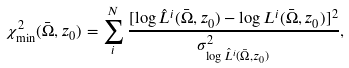Convert formula to latex. <formula><loc_0><loc_0><loc_500><loc_500>\chi ^ { 2 } _ { \min } ( \bar { \Omega } , z _ { 0 } ) = \sum _ { i } ^ { N } \frac { [ \log \hat { L } ^ { i } ( \bar { \Omega } , z _ { 0 } ) - \log L ^ { i } ( \bar { \Omega } , z _ { 0 } ) ] ^ { 2 } } { \sigma _ { \log \hat { L } ^ { i } ( \bar { \Omega } , z _ { 0 } ) } ^ { 2 } } ,</formula> 